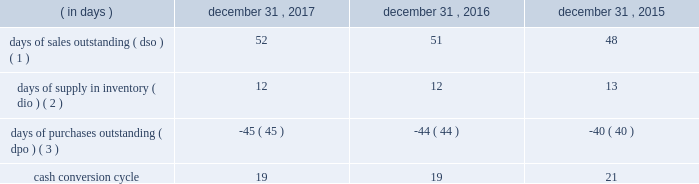Table of contents ( 4 ) the increase in cash flows was primarily due to the timing of inventory purchases and longer payment terms with certain vendors .
In order to manage our working capital and operating cash needs , we monitor our cash conversion cycle , defined as days of sales outstanding in accounts receivable plus days of supply in inventory minus days of purchases outstanding in accounts payable , based on a rolling three-month average .
Components of our cash conversion cycle are as follows: .
( 1 ) represents the rolling three-month average of the balance of accounts receivable , net at the end of the period , divided by average daily net sales for the same three-month period .
Also incorporates components of other miscellaneous receivables .
( 2 ) represents the rolling three-month average of the balance of merchandise inventory at the end of the period divided by average daily cost of sales for the same three-month period .
( 3 ) represents the rolling three-month average of the combined balance of accounts payable-trade , excluding cash overdrafts , and accounts payable-inventory financing at the end of the period divided by average daily cost of sales for the same three-month period .
The cash conversion cycle was 19 days at december 31 , 2017 and 2016 .
The increase in dso was primarily driven by higher net sales and related accounts receivable for third-party services such as saas , software assurance and warranties .
These services have an unfavorable impact on dso as the receivable is recognized on the consolidated balance sheet on a gross basis while the corresponding sales amount in the consolidated statement of operations is recorded on a net basis .
This also results in a favorable impact on dpo as the payable is recognized on the consolidated balance sheet without a corresponding cost of sales in the statement of operations because the cost paid to the vendor or third-party service provider is recorded as a reduction to net sales .
In addition , dpo also increased due to the mix of payables with certain vendors that have longer payment terms .
The cash conversion cycle was 19 and 21 days at december 31 , 2016 and 2015 , respectively .
The increase in dso was primarily driven by higher net sales and related accounts receivable for third-party services such as saas , software assurance and warranties .
These services have an unfavorable impact on dso as the receivable is recognized on the balance sheet on a gross basis while the corresponding sales amount in the statement of operations is recorded on a net basis .
These services have a favorable impact on dpo as the payable is recognized on the balance sheet without a corresponding cost of sale in the statement of operations because the cost paid to the vendor or third-party service provider is recorded as a reduction to net sales .
In addition to the impact of these services on dpo , dpo also increased due to the mix of payables with certain vendors that have longer payment terms .
Investing activities net cash used in investing activities increased $ 15 million in 2017 compared to 2016 .
Capital expenditures increased $ 17 million to $ 81 million from $ 64 million for 2017 and 2016 , respectively , primarily related to improvements to our information technology systems .
Net cash used in investing activities decreased $ 289 million in 2016 compared to 2015 .
The decrease in cash used was primarily due to the completion of the acquisition of cdw uk in 2015 .
Additionally , capital expenditures decreased $ 26 million to $ 64 million from $ 90 million for 2016 and 2015 , respectively , primarily due to spending for our new office location in 2015 .
Financing activities net cash used in financing activities increased $ 514 million in 2017 compared to 2016 .
The increase was primarily driven by changes in accounts payable-inventory financing , which resulted in an increase in cash used for financing activities of $ 228 million and by share repurchases during 2017 , which resulted in an increase in cash used for financing activities of $ 167 million .
For more information on our share repurchase program , see part ii , item 5 , 201cmarket for registrant 2019s common equity , related stockholder matters and issuer purchases of equity securities . 201d the increase in cash used for accounts payable-inventory financing was primarily driven by the termination of one of our inventory financing agreements in the fourth quarter of 2016 , with amounts .
By what percentage did the cash conversion cycle decrease from dec 31 , 2015 to dec 31 , 2016? 
Computations: (((21 - 19) / 21) * 100)
Answer: 9.52381. 